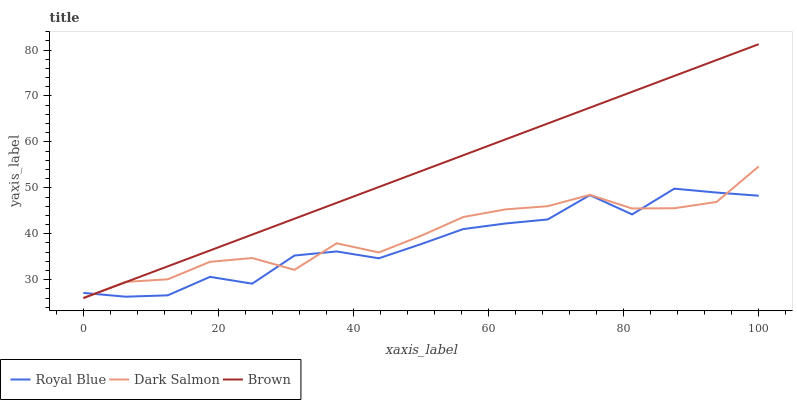Does Royal Blue have the minimum area under the curve?
Answer yes or no. Yes. Does Brown have the maximum area under the curve?
Answer yes or no. Yes. Does Dark Salmon have the minimum area under the curve?
Answer yes or no. No. Does Dark Salmon have the maximum area under the curve?
Answer yes or no. No. Is Brown the smoothest?
Answer yes or no. Yes. Is Royal Blue the roughest?
Answer yes or no. Yes. Is Dark Salmon the smoothest?
Answer yes or no. No. Is Dark Salmon the roughest?
Answer yes or no. No. Does Dark Salmon have the lowest value?
Answer yes or no. Yes. Does Brown have the highest value?
Answer yes or no. Yes. Does Dark Salmon have the highest value?
Answer yes or no. No. Does Brown intersect Royal Blue?
Answer yes or no. Yes. Is Brown less than Royal Blue?
Answer yes or no. No. Is Brown greater than Royal Blue?
Answer yes or no. No. 